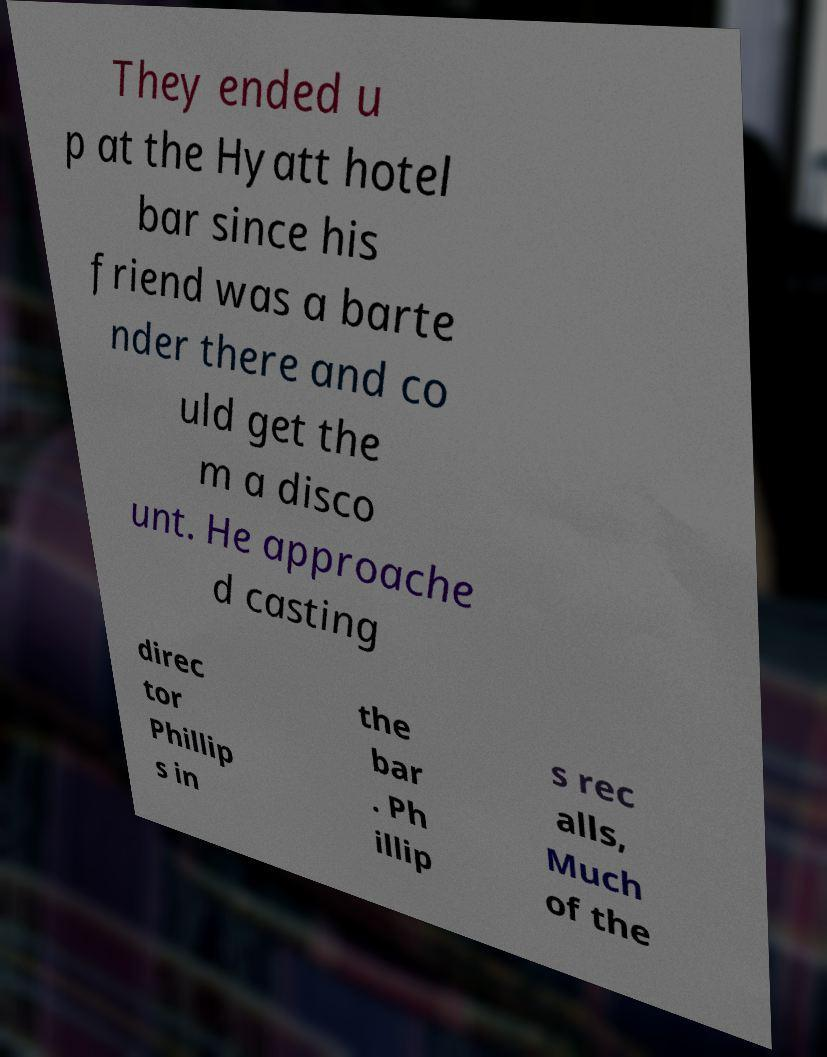Could you assist in decoding the text presented in this image and type it out clearly? They ended u p at the Hyatt hotel bar since his friend was a barte nder there and co uld get the m a disco unt. He approache d casting direc tor Phillip s in the bar . Ph illip s rec alls, Much of the 